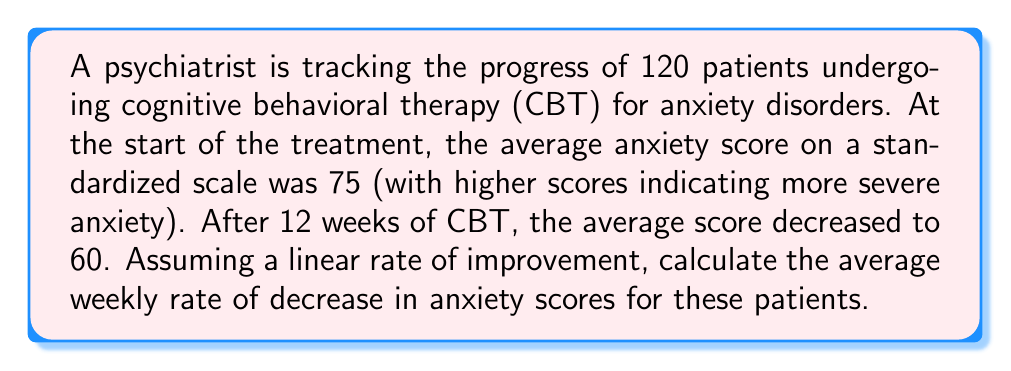Could you help me with this problem? To solve this problem, we need to follow these steps:

1. Identify the given information:
   - Initial average anxiety score: 75
   - Final average anxiety score: 60
   - Duration of treatment: 12 weeks
   - Number of patients: 120 (not directly relevant for this calculation)

2. Calculate the total decrease in anxiety scores:
   $$\text{Total decrease} = \text{Initial score} - \text{Final score}$$
   $$\text{Total decrease} = 75 - 60 = 15$$

3. Calculate the average weekly rate of decrease:
   $$\text{Weekly rate of decrease} = \frac{\text{Total decrease}}{\text{Number of weeks}}$$
   $$\text{Weekly rate of decrease} = \frac{15}{12}$$

4. Simplify the fraction:
   $$\text{Weekly rate of decrease} = \frac{5}{4} = 1.25$$

Therefore, the average weekly rate of decrease in anxiety scores is 1.25 points per week.
Answer: The average weekly rate of decrease in anxiety scores is 1.25 points per week. 